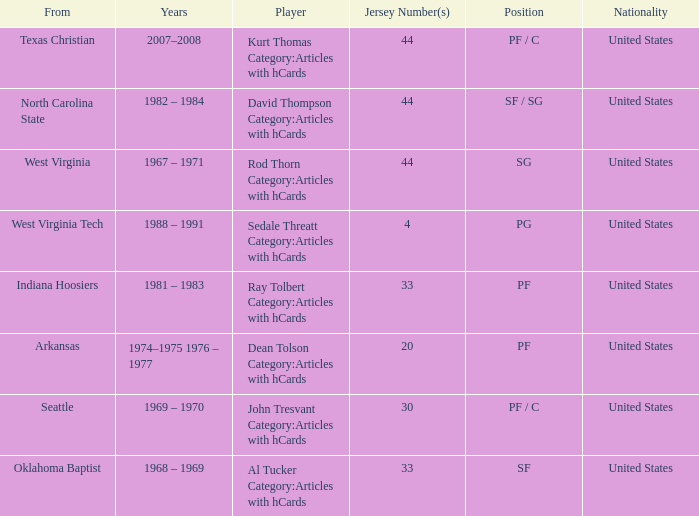What was the highest jersey number for the player from oklahoma baptist? 33.0. 